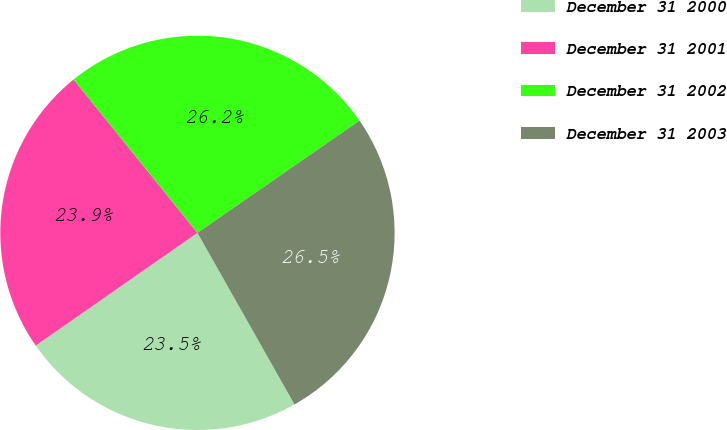<chart> <loc_0><loc_0><loc_500><loc_500><pie_chart><fcel>December 31 2000<fcel>December 31 2001<fcel>December 31 2002<fcel>December 31 2003<nl><fcel>23.5%<fcel>23.88%<fcel>26.17%<fcel>26.45%<nl></chart> 